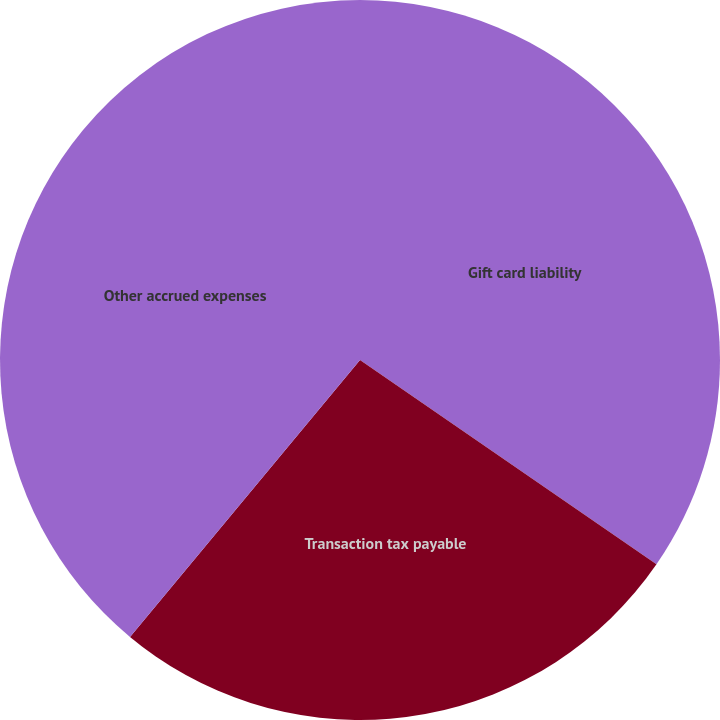<chart> <loc_0><loc_0><loc_500><loc_500><pie_chart><fcel>Gift card liability<fcel>Transaction tax payable<fcel>Other accrued expenses<nl><fcel>34.6%<fcel>26.43%<fcel>38.97%<nl></chart> 